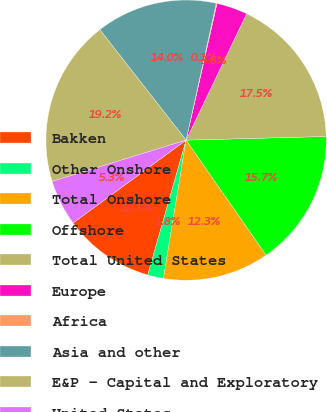Convert chart to OTSL. <chart><loc_0><loc_0><loc_500><loc_500><pie_chart><fcel>Bakken<fcel>Other Onshore<fcel>Total Onshore<fcel>Offshore<fcel>Total United States<fcel>Europe<fcel>Africa<fcel>Asia and other<fcel>E&P - Capital and Exploratory<fcel>United States<nl><fcel>10.52%<fcel>1.83%<fcel>12.26%<fcel>15.74%<fcel>17.47%<fcel>3.57%<fcel>0.09%<fcel>14.0%<fcel>19.21%<fcel>5.31%<nl></chart> 